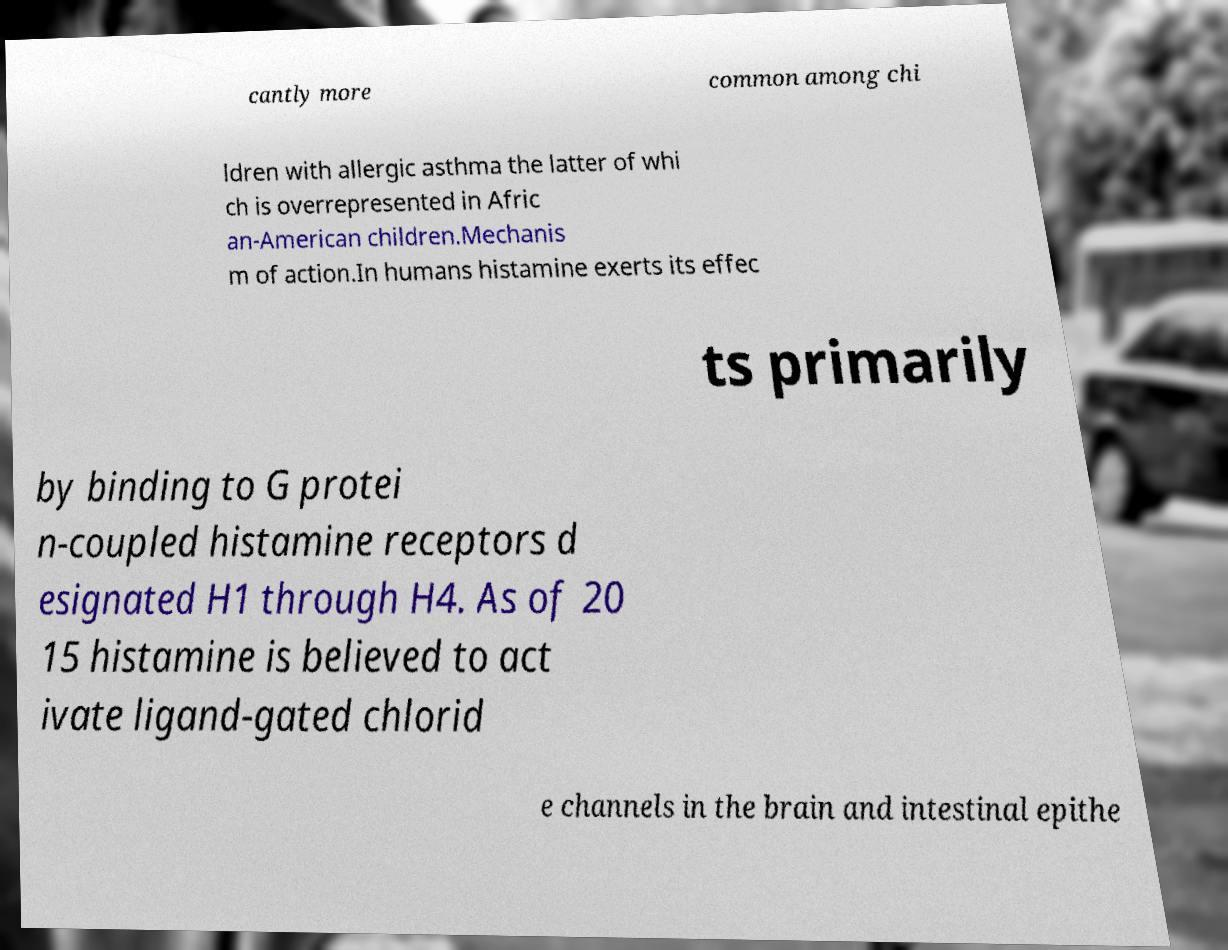For documentation purposes, I need the text within this image transcribed. Could you provide that? cantly more common among chi ldren with allergic asthma the latter of whi ch is overrepresented in Afric an-American children.Mechanis m of action.In humans histamine exerts its effec ts primarily by binding to G protei n-coupled histamine receptors d esignated H1 through H4. As of 20 15 histamine is believed to act ivate ligand-gated chlorid e channels in the brain and intestinal epithe 